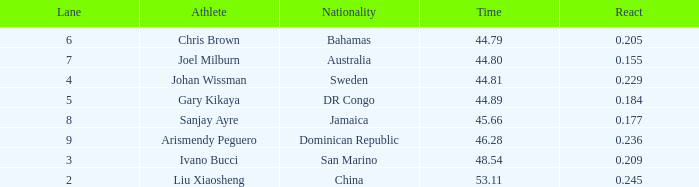209 react input with a rank entry greater than 6? 2.0. 